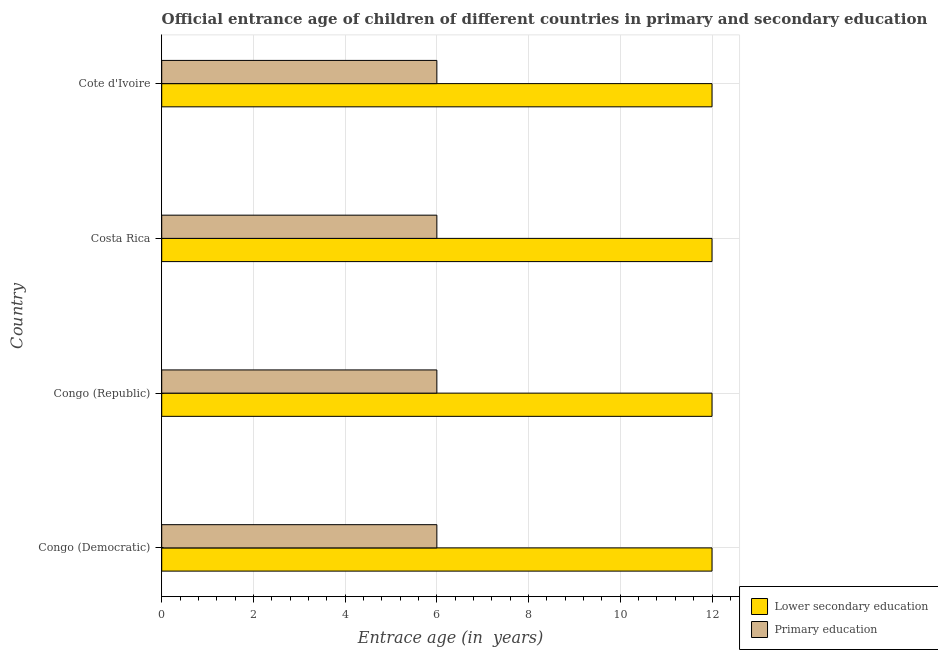How many groups of bars are there?
Offer a terse response. 4. Are the number of bars per tick equal to the number of legend labels?
Offer a terse response. Yes. Are the number of bars on each tick of the Y-axis equal?
Offer a very short reply. Yes. How many bars are there on the 4th tick from the bottom?
Make the answer very short. 2. In how many cases, is the number of bars for a given country not equal to the number of legend labels?
Your response must be concise. 0. What is the entrance age of chiildren in primary education in Congo (Democratic)?
Make the answer very short. 6. Across all countries, what is the maximum entrance age of chiildren in primary education?
Make the answer very short. 6. In which country was the entrance age of chiildren in primary education maximum?
Your answer should be very brief. Congo (Democratic). In which country was the entrance age of chiildren in primary education minimum?
Your answer should be compact. Congo (Democratic). What is the total entrance age of children in lower secondary education in the graph?
Keep it short and to the point. 48. What is the difference between the entrance age of chiildren in primary education in Costa Rica and that in Cote d'Ivoire?
Your answer should be very brief. 0. What is the difference between the entrance age of chiildren in primary education in Costa Rica and the entrance age of children in lower secondary education in Congo (Democratic)?
Offer a very short reply. -6. In how many countries, is the entrance age of chiildren in primary education greater than 12 years?
Your answer should be very brief. 0. What is the difference between the highest and the lowest entrance age of children in lower secondary education?
Offer a very short reply. 0. In how many countries, is the entrance age of chiildren in primary education greater than the average entrance age of chiildren in primary education taken over all countries?
Offer a terse response. 0. What does the 1st bar from the top in Cote d'Ivoire represents?
Your answer should be compact. Primary education. What does the 1st bar from the bottom in Costa Rica represents?
Your answer should be compact. Lower secondary education. How many bars are there?
Your answer should be very brief. 8. Are the values on the major ticks of X-axis written in scientific E-notation?
Offer a very short reply. No. Where does the legend appear in the graph?
Give a very brief answer. Bottom right. How many legend labels are there?
Give a very brief answer. 2. How are the legend labels stacked?
Your response must be concise. Vertical. What is the title of the graph?
Your answer should be very brief. Official entrance age of children of different countries in primary and secondary education. Does "Stunting" appear as one of the legend labels in the graph?
Offer a very short reply. No. What is the label or title of the X-axis?
Ensure brevity in your answer.  Entrace age (in  years). What is the label or title of the Y-axis?
Your answer should be very brief. Country. What is the Entrace age (in  years) of Primary education in Congo (Republic)?
Offer a very short reply. 6. What is the Entrace age (in  years) of Lower secondary education in Costa Rica?
Offer a terse response. 12. What is the Entrace age (in  years) in Lower secondary education in Cote d'Ivoire?
Offer a terse response. 12. What is the Entrace age (in  years) of Primary education in Cote d'Ivoire?
Keep it short and to the point. 6. Across all countries, what is the maximum Entrace age (in  years) of Lower secondary education?
Make the answer very short. 12. Across all countries, what is the maximum Entrace age (in  years) in Primary education?
Offer a very short reply. 6. Across all countries, what is the minimum Entrace age (in  years) in Lower secondary education?
Provide a succinct answer. 12. Across all countries, what is the minimum Entrace age (in  years) of Primary education?
Provide a succinct answer. 6. What is the total Entrace age (in  years) of Primary education in the graph?
Ensure brevity in your answer.  24. What is the difference between the Entrace age (in  years) in Lower secondary education in Congo (Democratic) and that in Congo (Republic)?
Ensure brevity in your answer.  0. What is the difference between the Entrace age (in  years) in Lower secondary education in Congo (Democratic) and that in Costa Rica?
Offer a very short reply. 0. What is the difference between the Entrace age (in  years) in Primary education in Congo (Democratic) and that in Cote d'Ivoire?
Your response must be concise. 0. What is the difference between the Entrace age (in  years) of Lower secondary education in Congo (Republic) and that in Costa Rica?
Provide a short and direct response. 0. What is the difference between the Entrace age (in  years) of Primary education in Congo (Republic) and that in Costa Rica?
Ensure brevity in your answer.  0. What is the difference between the Entrace age (in  years) of Lower secondary education in Congo (Republic) and that in Cote d'Ivoire?
Provide a short and direct response. 0. What is the difference between the Entrace age (in  years) in Primary education in Costa Rica and that in Cote d'Ivoire?
Offer a very short reply. 0. What is the difference between the Entrace age (in  years) in Lower secondary education in Congo (Democratic) and the Entrace age (in  years) in Primary education in Costa Rica?
Provide a short and direct response. 6. What is the difference between the Entrace age (in  years) in Lower secondary education in Congo (Republic) and the Entrace age (in  years) in Primary education in Costa Rica?
Offer a very short reply. 6. What is the average Entrace age (in  years) of Lower secondary education per country?
Your answer should be compact. 12. What is the average Entrace age (in  years) of Primary education per country?
Ensure brevity in your answer.  6. What is the difference between the Entrace age (in  years) in Lower secondary education and Entrace age (in  years) in Primary education in Congo (Republic)?
Provide a succinct answer. 6. What is the ratio of the Entrace age (in  years) in Lower secondary education in Congo (Democratic) to that in Congo (Republic)?
Provide a short and direct response. 1. What is the ratio of the Entrace age (in  years) in Lower secondary education in Congo (Democratic) to that in Costa Rica?
Provide a succinct answer. 1. What is the ratio of the Entrace age (in  years) in Primary education in Congo (Democratic) to that in Costa Rica?
Ensure brevity in your answer.  1. What is the ratio of the Entrace age (in  years) in Lower secondary education in Congo (Democratic) to that in Cote d'Ivoire?
Provide a short and direct response. 1. What is the ratio of the Entrace age (in  years) of Primary education in Congo (Democratic) to that in Cote d'Ivoire?
Make the answer very short. 1. What is the ratio of the Entrace age (in  years) of Lower secondary education in Congo (Republic) to that in Cote d'Ivoire?
Ensure brevity in your answer.  1. What is the ratio of the Entrace age (in  years) of Primary education in Congo (Republic) to that in Cote d'Ivoire?
Keep it short and to the point. 1. What is the ratio of the Entrace age (in  years) in Primary education in Costa Rica to that in Cote d'Ivoire?
Provide a succinct answer. 1. What is the difference between the highest and the second highest Entrace age (in  years) in Primary education?
Give a very brief answer. 0. What is the difference between the highest and the lowest Entrace age (in  years) of Primary education?
Provide a succinct answer. 0. 